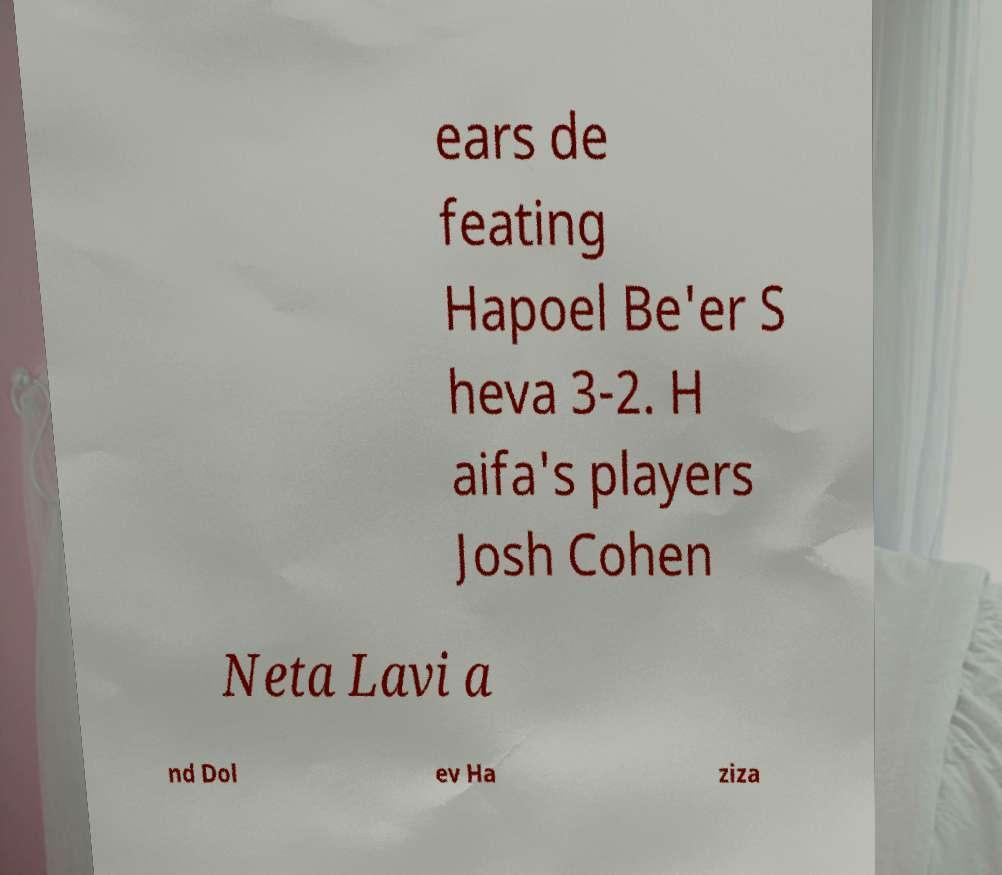I need the written content from this picture converted into text. Can you do that? ears de feating Hapoel Be'er S heva 3-2. H aifa's players Josh Cohen Neta Lavi a nd Dol ev Ha ziza 